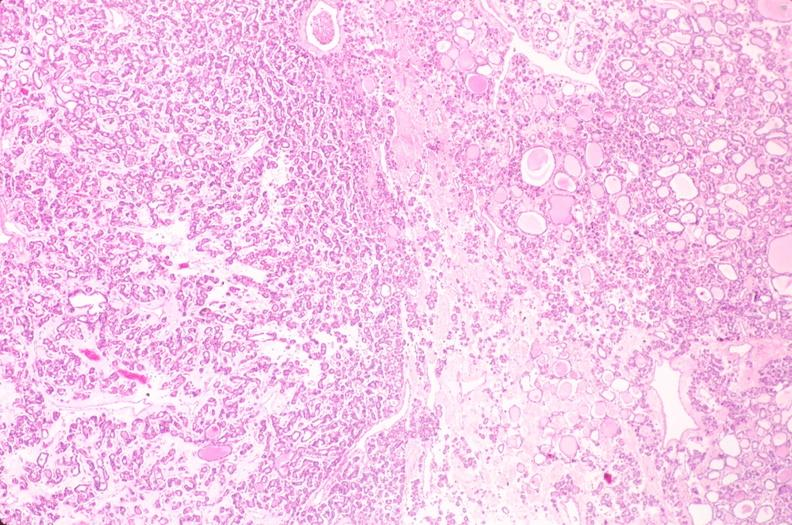does this image show thyroid, nodular hyperplasia?
Answer the question using a single word or phrase. Yes 